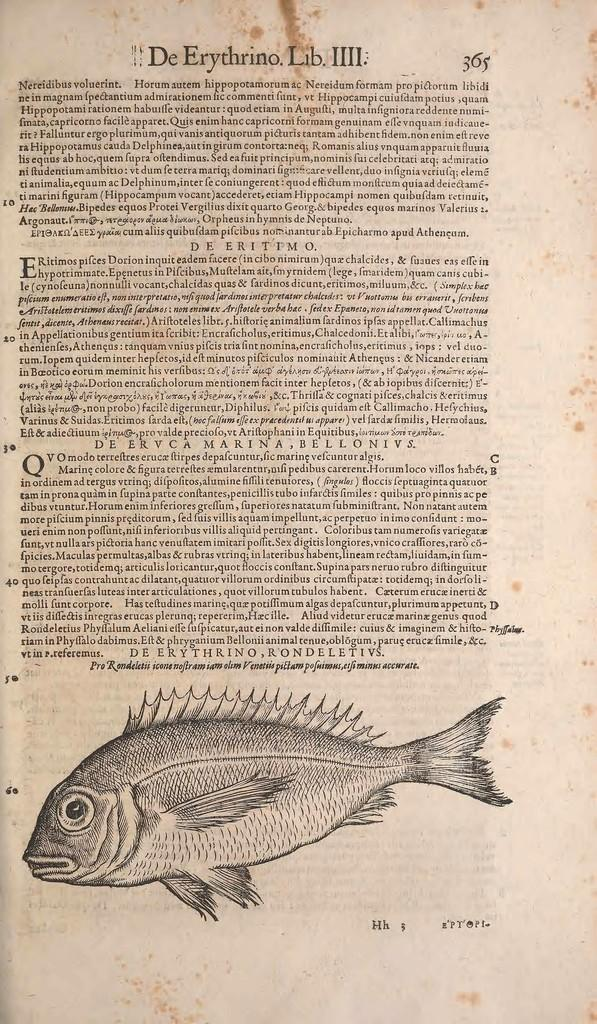What is the main object in the image? There is a paper in the image. What is depicted on the paper? The paper has a picture of a fish. Are there any words or symbols on the paper? Yes, there is text on the paper. What type of humor can be found in the image? There is no humor present in the image; it features a paper with a picture of a fish and text. Is there a cap visible in the image? There is no cap present in the image. 